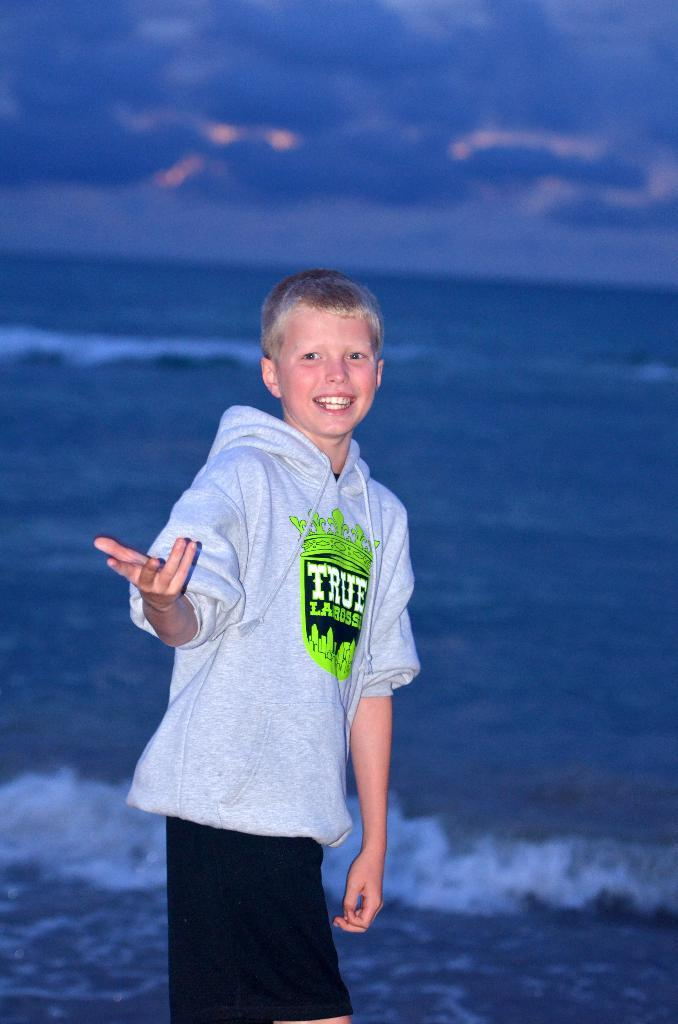What is the main subject of the image? The main subject of the image is a boy. What is the boy wearing in the image? The boy is wearing a hoodie. What can be seen in the background of the image? There is a sea visible in the background of the image. How would you describe the sky in the background of the image? The sky is cloudy in the background of the image. What type of day is depicted in the image? The provided facts do not specify whether it is day or night in the image. Is the boy in the image a fireman? There is no indication in the image that the boy is a fireman. Is the boy in the image engaged in a fight? There is no indication in the image that the boy is engaged in a fight. 